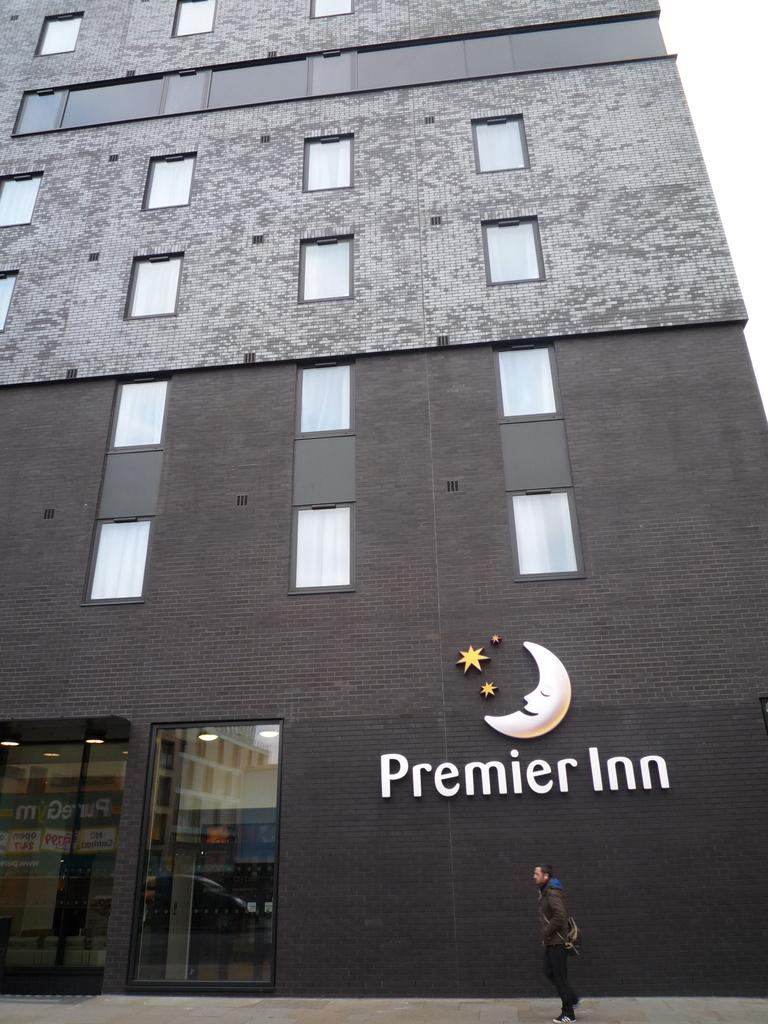Provide a one-sentence caption for the provided image. A man walking in front of a building that says Premier Inn. 